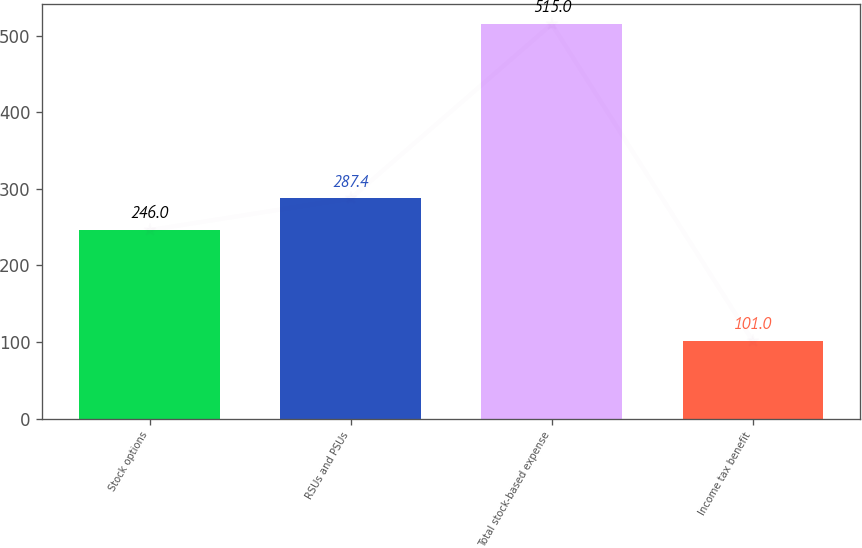<chart> <loc_0><loc_0><loc_500><loc_500><bar_chart><fcel>Stock options<fcel>RSUs and PSUs<fcel>Total stock-based expense<fcel>Income tax benefit<nl><fcel>246<fcel>287.4<fcel>515<fcel>101<nl></chart> 